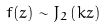Convert formula to latex. <formula><loc_0><loc_0><loc_500><loc_500>f ( z ) \sim J _ { 2 } \left ( k z \right )</formula> 